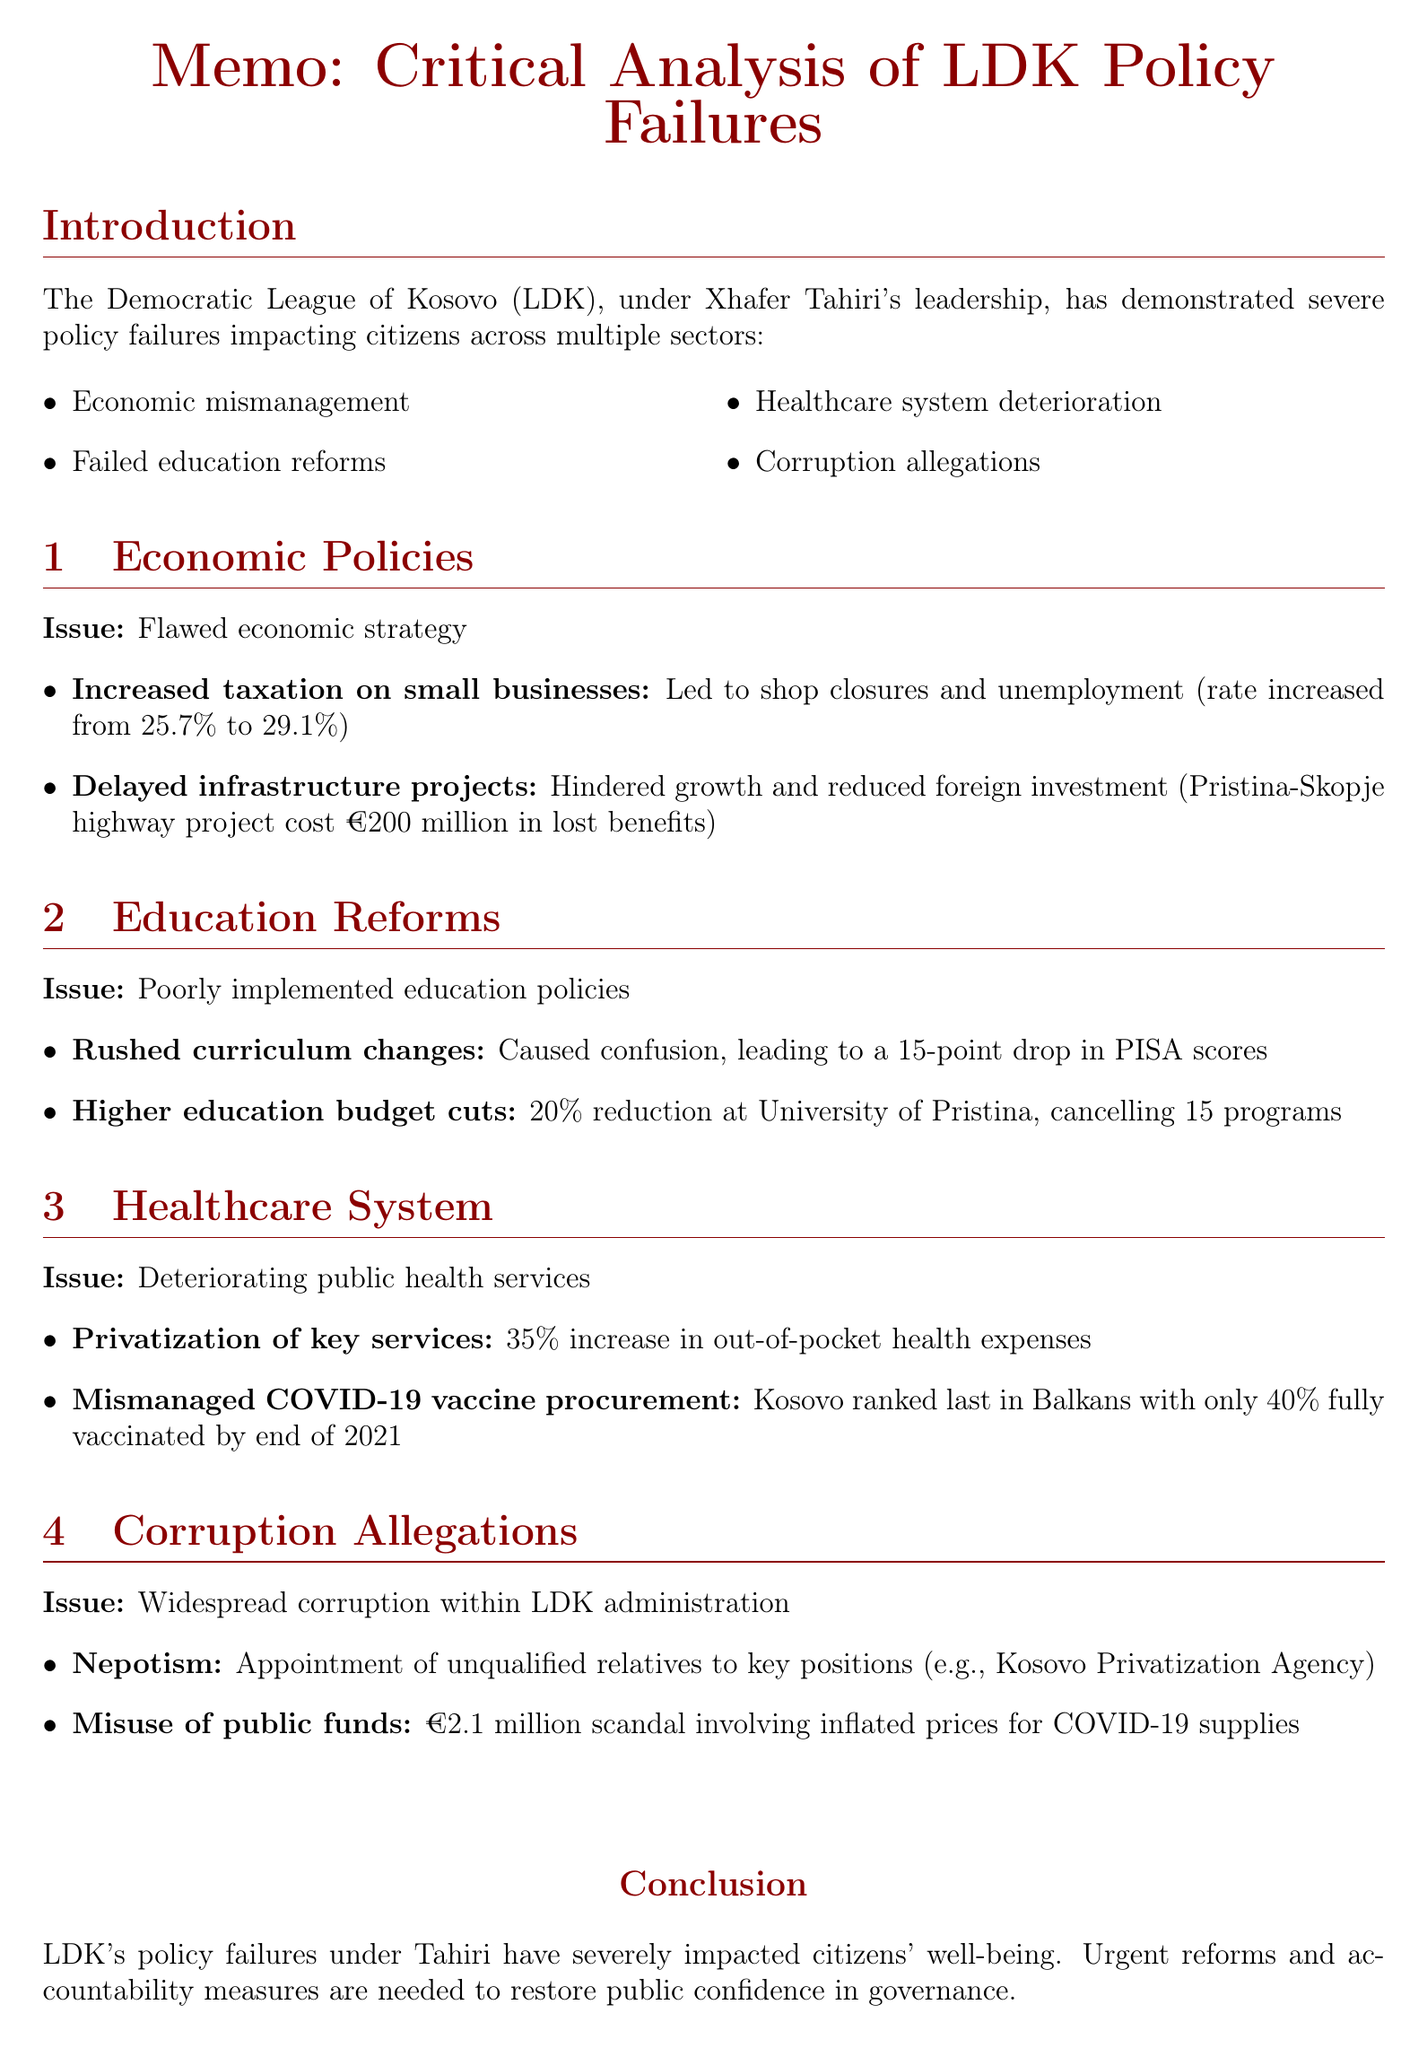What is the main conclusion of the memo? The main conclusion summarizes the policy failures of the LDK under Xhafer Tahiri's leadership and calls for urgent reforms; it states that these failures have severely impacted citizens' well-being.
Answer: Urgent reforms and accountability measures are needed to restore public confidence in governance What is the percentage increase in unemployment due to policy failures? The document states that unemployment increased from 25.7% to 29.1% due to economic mismanagement by the LDK.
Answer: 3.4% What was the budget reduction percentage at the University of Pristina? The memo details that the University of Pristina experienced a 20% budget reduction, affecting its programs negatively.
Answer: 20% What case study illustrates the consequences of delayed infrastructure projects? The stalled Pristina-Skopje highway project is cited as a significant case study regarding delays, which has had a large economic cost.
Answer: The stalled Pristina-Skopje highway project has cost the economy an estimated €200 million in potential benefits What policy led to a 35% increase in healthcare costs for families? The document states that the privatization of key health services caused a significant rise in out-of-pocket health expenses for citizens.
Answer: Privatization of key health services How did the rushed curriculum changes affect students? The memo indicates that rushed curriculum changes resulted in confusion among teachers and students, linked to declining test scores.
Answer: Declining test scores What type of corruption is highlighted regarding government appointments? The document highlights nepotism in government appointments as a major issue affecting governance and public trust.
Answer: Nepotism in government appointments Which healthcare policy resulted in a delay of vaccination rollout? The mismanagement of COVID-19 vaccine procurement is cited as the policy that led to delays in vaccination rollout in Kosovo.
Answer: Mismanagement of COVID-19 vaccine procurement 